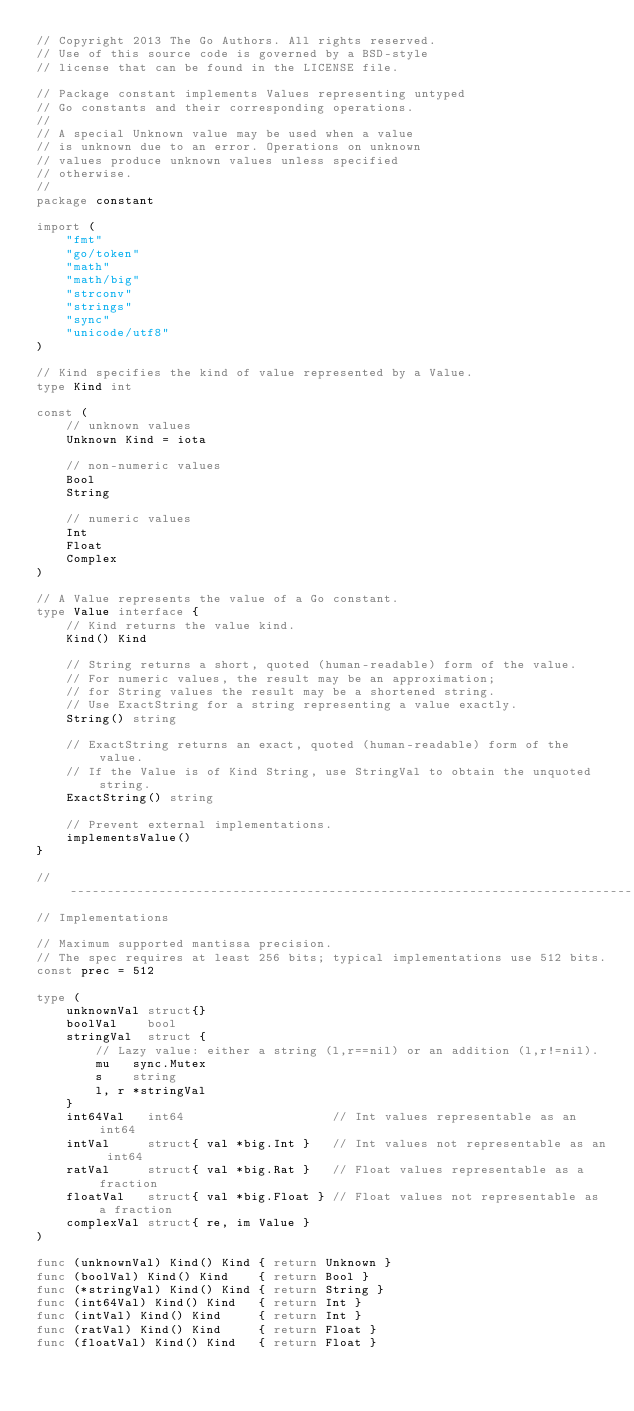<code> <loc_0><loc_0><loc_500><loc_500><_Go_>// Copyright 2013 The Go Authors. All rights reserved.
// Use of this source code is governed by a BSD-style
// license that can be found in the LICENSE file.

// Package constant implements Values representing untyped
// Go constants and their corresponding operations.
//
// A special Unknown value may be used when a value
// is unknown due to an error. Operations on unknown
// values produce unknown values unless specified
// otherwise.
//
package constant

import (
	"fmt"
	"go/token"
	"math"
	"math/big"
	"strconv"
	"strings"
	"sync"
	"unicode/utf8"
)

// Kind specifies the kind of value represented by a Value.
type Kind int

const (
	// unknown values
	Unknown Kind = iota

	// non-numeric values
	Bool
	String

	// numeric values
	Int
	Float
	Complex
)

// A Value represents the value of a Go constant.
type Value interface {
	// Kind returns the value kind.
	Kind() Kind

	// String returns a short, quoted (human-readable) form of the value.
	// For numeric values, the result may be an approximation;
	// for String values the result may be a shortened string.
	// Use ExactString for a string representing a value exactly.
	String() string

	// ExactString returns an exact, quoted (human-readable) form of the value.
	// If the Value is of Kind String, use StringVal to obtain the unquoted string.
	ExactString() string

	// Prevent external implementations.
	implementsValue()
}

// ----------------------------------------------------------------------------
// Implementations

// Maximum supported mantissa precision.
// The spec requires at least 256 bits; typical implementations use 512 bits.
const prec = 512

type (
	unknownVal struct{}
	boolVal    bool
	stringVal  struct {
		// Lazy value: either a string (l,r==nil) or an addition (l,r!=nil).
		mu   sync.Mutex
		s    string
		l, r *stringVal
	}
	int64Val   int64                    // Int values representable as an int64
	intVal     struct{ val *big.Int }   // Int values not representable as an int64
	ratVal     struct{ val *big.Rat }   // Float values representable as a fraction
	floatVal   struct{ val *big.Float } // Float values not representable as a fraction
	complexVal struct{ re, im Value }
)

func (unknownVal) Kind() Kind { return Unknown }
func (boolVal) Kind() Kind    { return Bool }
func (*stringVal) Kind() Kind { return String }
func (int64Val) Kind() Kind   { return Int }
func (intVal) Kind() Kind     { return Int }
func (ratVal) Kind() Kind     { return Float }
func (floatVal) Kind() Kind   { return Float }</code> 